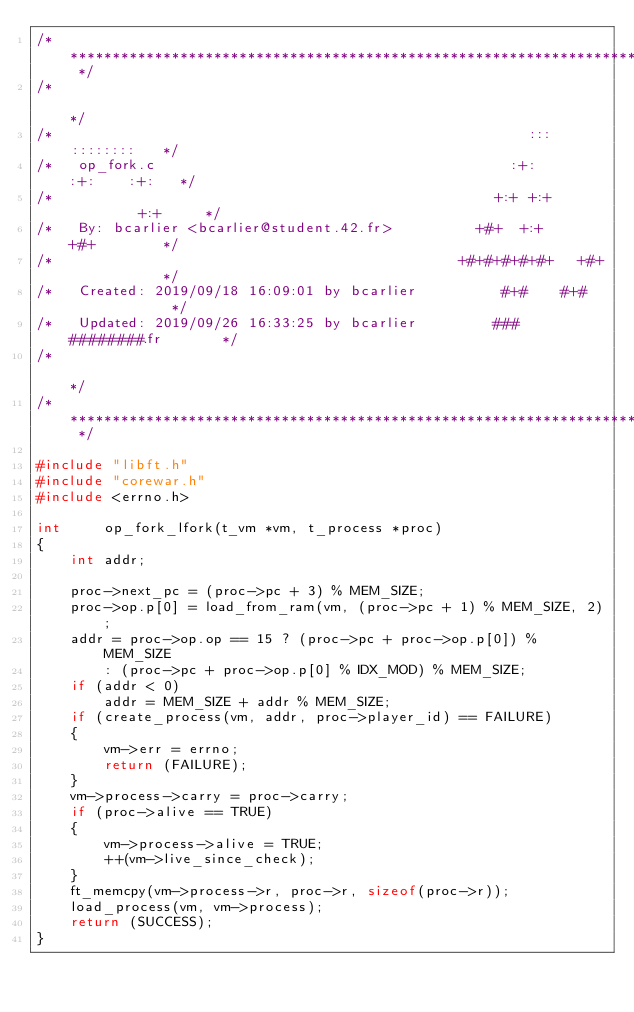<code> <loc_0><loc_0><loc_500><loc_500><_C_>/* ************************************************************************** */
/*                                                                            */
/*                                                        :::      ::::::::   */
/*   op_fork.c                                          :+:      :+:    :+:   */
/*                                                    +:+ +:+         +:+     */
/*   By: bcarlier <bcarlier@student.42.fr>          +#+  +:+       +#+        */
/*                                                +#+#+#+#+#+   +#+           */
/*   Created: 2019/09/18 16:09:01 by bcarlier          #+#    #+#             */
/*   Updated: 2019/09/26 16:33:25 by bcarlier         ###   ########.fr       */
/*                                                                            */
/* ************************************************************************** */

#include "libft.h"
#include "corewar.h"
#include <errno.h>

int		op_fork_lfork(t_vm *vm, t_process *proc)
{
	int	addr;

	proc->next_pc = (proc->pc + 3) % MEM_SIZE;
	proc->op.p[0] = load_from_ram(vm, (proc->pc + 1) % MEM_SIZE, 2);
	addr = proc->op.op == 15 ? (proc->pc + proc->op.p[0]) % MEM_SIZE
		: (proc->pc + proc->op.p[0] % IDX_MOD) % MEM_SIZE;
	if (addr < 0)
		addr = MEM_SIZE + addr % MEM_SIZE;
	if (create_process(vm, addr, proc->player_id) == FAILURE)
	{
		vm->err = errno;
		return (FAILURE);
	}
	vm->process->carry = proc->carry;
	if (proc->alive == TRUE)
	{
		vm->process->alive = TRUE;
		++(vm->live_since_check);
	}
	ft_memcpy(vm->process->r, proc->r, sizeof(proc->r));
	load_process(vm, vm->process);
	return (SUCCESS);
}
</code> 